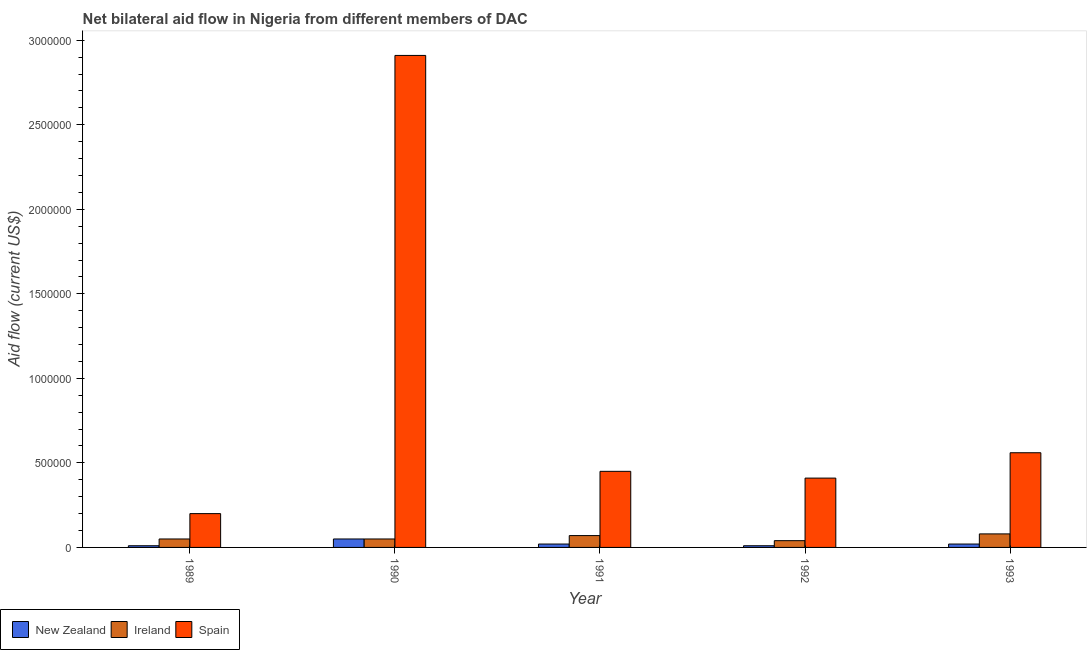Are the number of bars per tick equal to the number of legend labels?
Give a very brief answer. Yes. How many bars are there on the 4th tick from the right?
Offer a terse response. 3. What is the label of the 1st group of bars from the left?
Offer a terse response. 1989. In how many cases, is the number of bars for a given year not equal to the number of legend labels?
Make the answer very short. 0. What is the amount of aid provided by ireland in 1990?
Give a very brief answer. 5.00e+04. Across all years, what is the maximum amount of aid provided by new zealand?
Offer a terse response. 5.00e+04. Across all years, what is the minimum amount of aid provided by ireland?
Keep it short and to the point. 4.00e+04. What is the total amount of aid provided by new zealand in the graph?
Keep it short and to the point. 1.10e+05. What is the difference between the amount of aid provided by spain in 1990 and that in 1993?
Make the answer very short. 2.35e+06. What is the difference between the amount of aid provided by spain in 1993 and the amount of aid provided by ireland in 1991?
Offer a terse response. 1.10e+05. What is the average amount of aid provided by spain per year?
Keep it short and to the point. 9.06e+05. In the year 1991, what is the difference between the amount of aid provided by spain and amount of aid provided by new zealand?
Provide a succinct answer. 0. In how many years, is the amount of aid provided by spain greater than 1600000 US$?
Offer a terse response. 1. What is the ratio of the amount of aid provided by ireland in 1991 to that in 1993?
Give a very brief answer. 0.88. Is the amount of aid provided by new zealand in 1989 less than that in 1990?
Give a very brief answer. Yes. What is the difference between the highest and the second highest amount of aid provided by new zealand?
Offer a terse response. 3.00e+04. What is the difference between the highest and the lowest amount of aid provided by spain?
Give a very brief answer. 2.71e+06. In how many years, is the amount of aid provided by spain greater than the average amount of aid provided by spain taken over all years?
Make the answer very short. 1. Is the sum of the amount of aid provided by new zealand in 1990 and 1993 greater than the maximum amount of aid provided by ireland across all years?
Keep it short and to the point. Yes. What does the 1st bar from the right in 1991 represents?
Offer a terse response. Spain. Is it the case that in every year, the sum of the amount of aid provided by new zealand and amount of aid provided by ireland is greater than the amount of aid provided by spain?
Your answer should be compact. No. Are all the bars in the graph horizontal?
Make the answer very short. No. How many years are there in the graph?
Your response must be concise. 5. Are the values on the major ticks of Y-axis written in scientific E-notation?
Your answer should be compact. No. Where does the legend appear in the graph?
Offer a very short reply. Bottom left. How many legend labels are there?
Keep it short and to the point. 3. What is the title of the graph?
Give a very brief answer. Net bilateral aid flow in Nigeria from different members of DAC. What is the label or title of the Y-axis?
Provide a short and direct response. Aid flow (current US$). What is the Aid flow (current US$) in New Zealand in 1989?
Give a very brief answer. 10000. What is the Aid flow (current US$) in Ireland in 1990?
Offer a very short reply. 5.00e+04. What is the Aid flow (current US$) of Spain in 1990?
Provide a short and direct response. 2.91e+06. What is the Aid flow (current US$) of Spain in 1991?
Keep it short and to the point. 4.50e+05. What is the Aid flow (current US$) of Ireland in 1992?
Your answer should be compact. 4.00e+04. What is the Aid flow (current US$) in Spain in 1992?
Make the answer very short. 4.10e+05. What is the Aid flow (current US$) in New Zealand in 1993?
Provide a short and direct response. 2.00e+04. What is the Aid flow (current US$) in Spain in 1993?
Provide a short and direct response. 5.60e+05. Across all years, what is the maximum Aid flow (current US$) in New Zealand?
Ensure brevity in your answer.  5.00e+04. Across all years, what is the maximum Aid flow (current US$) of Spain?
Your answer should be very brief. 2.91e+06. Across all years, what is the minimum Aid flow (current US$) in New Zealand?
Keep it short and to the point. 10000. Across all years, what is the minimum Aid flow (current US$) in Ireland?
Give a very brief answer. 4.00e+04. What is the total Aid flow (current US$) of New Zealand in the graph?
Offer a very short reply. 1.10e+05. What is the total Aid flow (current US$) of Ireland in the graph?
Your answer should be compact. 2.90e+05. What is the total Aid flow (current US$) in Spain in the graph?
Give a very brief answer. 4.53e+06. What is the difference between the Aid flow (current US$) in Spain in 1989 and that in 1990?
Make the answer very short. -2.71e+06. What is the difference between the Aid flow (current US$) of New Zealand in 1989 and that in 1991?
Keep it short and to the point. -10000. What is the difference between the Aid flow (current US$) in Spain in 1989 and that in 1992?
Make the answer very short. -2.10e+05. What is the difference between the Aid flow (current US$) of Ireland in 1989 and that in 1993?
Offer a terse response. -3.00e+04. What is the difference between the Aid flow (current US$) of Spain in 1989 and that in 1993?
Give a very brief answer. -3.60e+05. What is the difference between the Aid flow (current US$) of New Zealand in 1990 and that in 1991?
Keep it short and to the point. 3.00e+04. What is the difference between the Aid flow (current US$) of Spain in 1990 and that in 1991?
Your response must be concise. 2.46e+06. What is the difference between the Aid flow (current US$) of New Zealand in 1990 and that in 1992?
Offer a very short reply. 4.00e+04. What is the difference between the Aid flow (current US$) of Ireland in 1990 and that in 1992?
Your answer should be compact. 10000. What is the difference between the Aid flow (current US$) of Spain in 1990 and that in 1992?
Offer a terse response. 2.50e+06. What is the difference between the Aid flow (current US$) in New Zealand in 1990 and that in 1993?
Make the answer very short. 3.00e+04. What is the difference between the Aid flow (current US$) in Ireland in 1990 and that in 1993?
Give a very brief answer. -3.00e+04. What is the difference between the Aid flow (current US$) in Spain in 1990 and that in 1993?
Make the answer very short. 2.35e+06. What is the difference between the Aid flow (current US$) of Ireland in 1991 and that in 1992?
Provide a short and direct response. 3.00e+04. What is the difference between the Aid flow (current US$) in Spain in 1991 and that in 1992?
Offer a terse response. 4.00e+04. What is the difference between the Aid flow (current US$) of Spain in 1991 and that in 1993?
Keep it short and to the point. -1.10e+05. What is the difference between the Aid flow (current US$) of New Zealand in 1992 and that in 1993?
Make the answer very short. -10000. What is the difference between the Aid flow (current US$) of Ireland in 1992 and that in 1993?
Give a very brief answer. -4.00e+04. What is the difference between the Aid flow (current US$) in New Zealand in 1989 and the Aid flow (current US$) in Spain in 1990?
Give a very brief answer. -2.90e+06. What is the difference between the Aid flow (current US$) in Ireland in 1989 and the Aid flow (current US$) in Spain in 1990?
Provide a short and direct response. -2.86e+06. What is the difference between the Aid flow (current US$) of New Zealand in 1989 and the Aid flow (current US$) of Ireland in 1991?
Keep it short and to the point. -6.00e+04. What is the difference between the Aid flow (current US$) in New Zealand in 1989 and the Aid flow (current US$) in Spain in 1991?
Your answer should be very brief. -4.40e+05. What is the difference between the Aid flow (current US$) of Ireland in 1989 and the Aid flow (current US$) of Spain in 1991?
Ensure brevity in your answer.  -4.00e+05. What is the difference between the Aid flow (current US$) of New Zealand in 1989 and the Aid flow (current US$) of Ireland in 1992?
Offer a very short reply. -3.00e+04. What is the difference between the Aid flow (current US$) in New Zealand in 1989 and the Aid flow (current US$) in Spain in 1992?
Provide a succinct answer. -4.00e+05. What is the difference between the Aid flow (current US$) of Ireland in 1989 and the Aid flow (current US$) of Spain in 1992?
Give a very brief answer. -3.60e+05. What is the difference between the Aid flow (current US$) in New Zealand in 1989 and the Aid flow (current US$) in Spain in 1993?
Offer a very short reply. -5.50e+05. What is the difference between the Aid flow (current US$) of Ireland in 1989 and the Aid flow (current US$) of Spain in 1993?
Provide a succinct answer. -5.10e+05. What is the difference between the Aid flow (current US$) in New Zealand in 1990 and the Aid flow (current US$) in Spain in 1991?
Your answer should be compact. -4.00e+05. What is the difference between the Aid flow (current US$) of Ireland in 1990 and the Aid flow (current US$) of Spain in 1991?
Provide a succinct answer. -4.00e+05. What is the difference between the Aid flow (current US$) in New Zealand in 1990 and the Aid flow (current US$) in Ireland in 1992?
Provide a short and direct response. 10000. What is the difference between the Aid flow (current US$) of New Zealand in 1990 and the Aid flow (current US$) of Spain in 1992?
Provide a short and direct response. -3.60e+05. What is the difference between the Aid flow (current US$) of Ireland in 1990 and the Aid flow (current US$) of Spain in 1992?
Your response must be concise. -3.60e+05. What is the difference between the Aid flow (current US$) of New Zealand in 1990 and the Aid flow (current US$) of Ireland in 1993?
Your answer should be compact. -3.00e+04. What is the difference between the Aid flow (current US$) in New Zealand in 1990 and the Aid flow (current US$) in Spain in 1993?
Offer a very short reply. -5.10e+05. What is the difference between the Aid flow (current US$) in Ireland in 1990 and the Aid flow (current US$) in Spain in 1993?
Ensure brevity in your answer.  -5.10e+05. What is the difference between the Aid flow (current US$) in New Zealand in 1991 and the Aid flow (current US$) in Spain in 1992?
Offer a terse response. -3.90e+05. What is the difference between the Aid flow (current US$) in Ireland in 1991 and the Aid flow (current US$) in Spain in 1992?
Give a very brief answer. -3.40e+05. What is the difference between the Aid flow (current US$) of New Zealand in 1991 and the Aid flow (current US$) of Spain in 1993?
Offer a terse response. -5.40e+05. What is the difference between the Aid flow (current US$) in Ireland in 1991 and the Aid flow (current US$) in Spain in 1993?
Your answer should be compact. -4.90e+05. What is the difference between the Aid flow (current US$) in New Zealand in 1992 and the Aid flow (current US$) in Spain in 1993?
Ensure brevity in your answer.  -5.50e+05. What is the difference between the Aid flow (current US$) in Ireland in 1992 and the Aid flow (current US$) in Spain in 1993?
Offer a terse response. -5.20e+05. What is the average Aid flow (current US$) of New Zealand per year?
Provide a short and direct response. 2.20e+04. What is the average Aid flow (current US$) of Ireland per year?
Give a very brief answer. 5.80e+04. What is the average Aid flow (current US$) of Spain per year?
Keep it short and to the point. 9.06e+05. In the year 1990, what is the difference between the Aid flow (current US$) in New Zealand and Aid flow (current US$) in Ireland?
Provide a succinct answer. 0. In the year 1990, what is the difference between the Aid flow (current US$) in New Zealand and Aid flow (current US$) in Spain?
Your answer should be compact. -2.86e+06. In the year 1990, what is the difference between the Aid flow (current US$) in Ireland and Aid flow (current US$) in Spain?
Offer a very short reply. -2.86e+06. In the year 1991, what is the difference between the Aid flow (current US$) of New Zealand and Aid flow (current US$) of Ireland?
Make the answer very short. -5.00e+04. In the year 1991, what is the difference between the Aid flow (current US$) in New Zealand and Aid flow (current US$) in Spain?
Keep it short and to the point. -4.30e+05. In the year 1991, what is the difference between the Aid flow (current US$) in Ireland and Aid flow (current US$) in Spain?
Provide a short and direct response. -3.80e+05. In the year 1992, what is the difference between the Aid flow (current US$) in New Zealand and Aid flow (current US$) in Ireland?
Make the answer very short. -3.00e+04. In the year 1992, what is the difference between the Aid flow (current US$) in New Zealand and Aid flow (current US$) in Spain?
Your response must be concise. -4.00e+05. In the year 1992, what is the difference between the Aid flow (current US$) in Ireland and Aid flow (current US$) in Spain?
Give a very brief answer. -3.70e+05. In the year 1993, what is the difference between the Aid flow (current US$) of New Zealand and Aid flow (current US$) of Spain?
Your response must be concise. -5.40e+05. In the year 1993, what is the difference between the Aid flow (current US$) in Ireland and Aid flow (current US$) in Spain?
Make the answer very short. -4.80e+05. What is the ratio of the Aid flow (current US$) of Spain in 1989 to that in 1990?
Give a very brief answer. 0.07. What is the ratio of the Aid flow (current US$) in New Zealand in 1989 to that in 1991?
Provide a succinct answer. 0.5. What is the ratio of the Aid flow (current US$) in Ireland in 1989 to that in 1991?
Provide a succinct answer. 0.71. What is the ratio of the Aid flow (current US$) of Spain in 1989 to that in 1991?
Ensure brevity in your answer.  0.44. What is the ratio of the Aid flow (current US$) of Ireland in 1989 to that in 1992?
Your answer should be very brief. 1.25. What is the ratio of the Aid flow (current US$) in Spain in 1989 to that in 1992?
Provide a succinct answer. 0.49. What is the ratio of the Aid flow (current US$) of New Zealand in 1989 to that in 1993?
Your answer should be very brief. 0.5. What is the ratio of the Aid flow (current US$) in Ireland in 1989 to that in 1993?
Give a very brief answer. 0.62. What is the ratio of the Aid flow (current US$) of Spain in 1989 to that in 1993?
Your answer should be compact. 0.36. What is the ratio of the Aid flow (current US$) in New Zealand in 1990 to that in 1991?
Offer a very short reply. 2.5. What is the ratio of the Aid flow (current US$) of Ireland in 1990 to that in 1991?
Offer a very short reply. 0.71. What is the ratio of the Aid flow (current US$) of Spain in 1990 to that in 1991?
Keep it short and to the point. 6.47. What is the ratio of the Aid flow (current US$) in New Zealand in 1990 to that in 1992?
Make the answer very short. 5. What is the ratio of the Aid flow (current US$) in Ireland in 1990 to that in 1992?
Your answer should be very brief. 1.25. What is the ratio of the Aid flow (current US$) in Spain in 1990 to that in 1992?
Keep it short and to the point. 7.1. What is the ratio of the Aid flow (current US$) in Ireland in 1990 to that in 1993?
Ensure brevity in your answer.  0.62. What is the ratio of the Aid flow (current US$) of Spain in 1990 to that in 1993?
Offer a very short reply. 5.2. What is the ratio of the Aid flow (current US$) in New Zealand in 1991 to that in 1992?
Offer a very short reply. 2. What is the ratio of the Aid flow (current US$) in Spain in 1991 to that in 1992?
Provide a succinct answer. 1.1. What is the ratio of the Aid flow (current US$) in New Zealand in 1991 to that in 1993?
Give a very brief answer. 1. What is the ratio of the Aid flow (current US$) of Spain in 1991 to that in 1993?
Your response must be concise. 0.8. What is the ratio of the Aid flow (current US$) in New Zealand in 1992 to that in 1993?
Make the answer very short. 0.5. What is the ratio of the Aid flow (current US$) in Ireland in 1992 to that in 1993?
Your answer should be very brief. 0.5. What is the ratio of the Aid flow (current US$) of Spain in 1992 to that in 1993?
Keep it short and to the point. 0.73. What is the difference between the highest and the second highest Aid flow (current US$) of Spain?
Your answer should be very brief. 2.35e+06. What is the difference between the highest and the lowest Aid flow (current US$) of New Zealand?
Ensure brevity in your answer.  4.00e+04. What is the difference between the highest and the lowest Aid flow (current US$) of Ireland?
Ensure brevity in your answer.  4.00e+04. What is the difference between the highest and the lowest Aid flow (current US$) in Spain?
Ensure brevity in your answer.  2.71e+06. 